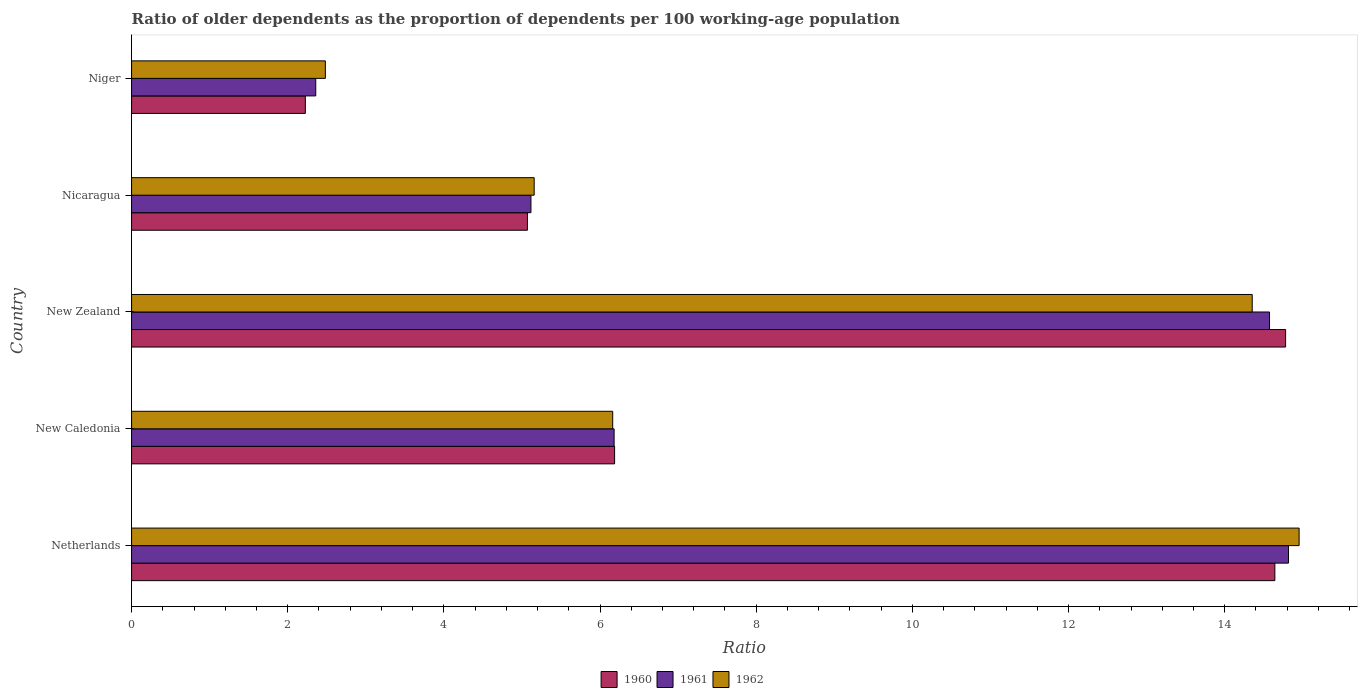How many groups of bars are there?
Your response must be concise. 5. Are the number of bars per tick equal to the number of legend labels?
Your answer should be compact. Yes. Are the number of bars on each tick of the Y-axis equal?
Provide a short and direct response. Yes. How many bars are there on the 4th tick from the top?
Your response must be concise. 3. What is the label of the 3rd group of bars from the top?
Your answer should be compact. New Zealand. What is the age dependency ratio(old) in 1961 in Netherlands?
Your answer should be compact. 14.82. Across all countries, what is the maximum age dependency ratio(old) in 1961?
Make the answer very short. 14.82. Across all countries, what is the minimum age dependency ratio(old) in 1962?
Provide a succinct answer. 2.48. In which country was the age dependency ratio(old) in 1961 minimum?
Your answer should be compact. Niger. What is the total age dependency ratio(old) in 1961 in the graph?
Provide a succinct answer. 43.04. What is the difference between the age dependency ratio(old) in 1962 in Netherlands and that in New Zealand?
Offer a terse response. 0.6. What is the difference between the age dependency ratio(old) in 1961 in New Zealand and the age dependency ratio(old) in 1962 in Nicaragua?
Make the answer very short. 9.42. What is the average age dependency ratio(old) in 1960 per country?
Your response must be concise. 8.58. What is the difference between the age dependency ratio(old) in 1960 and age dependency ratio(old) in 1961 in New Caledonia?
Keep it short and to the point. 0.01. In how many countries, is the age dependency ratio(old) in 1962 greater than 5.6 ?
Give a very brief answer. 3. What is the ratio of the age dependency ratio(old) in 1962 in New Caledonia to that in Niger?
Your answer should be very brief. 2.48. Is the difference between the age dependency ratio(old) in 1960 in New Caledonia and Nicaragua greater than the difference between the age dependency ratio(old) in 1961 in New Caledonia and Nicaragua?
Keep it short and to the point. Yes. What is the difference between the highest and the second highest age dependency ratio(old) in 1961?
Keep it short and to the point. 0.24. What is the difference between the highest and the lowest age dependency ratio(old) in 1962?
Keep it short and to the point. 12.47. Is it the case that in every country, the sum of the age dependency ratio(old) in 1960 and age dependency ratio(old) in 1962 is greater than the age dependency ratio(old) in 1961?
Offer a terse response. Yes. How many bars are there?
Your response must be concise. 15. How many countries are there in the graph?
Offer a very short reply. 5. Are the values on the major ticks of X-axis written in scientific E-notation?
Offer a very short reply. No. Does the graph contain any zero values?
Make the answer very short. No. Does the graph contain grids?
Keep it short and to the point. No. How many legend labels are there?
Make the answer very short. 3. What is the title of the graph?
Offer a very short reply. Ratio of older dependents as the proportion of dependents per 100 working-age population. Does "1987" appear as one of the legend labels in the graph?
Offer a terse response. No. What is the label or title of the X-axis?
Your response must be concise. Ratio. What is the Ratio in 1960 in Netherlands?
Your response must be concise. 14.64. What is the Ratio of 1961 in Netherlands?
Your answer should be compact. 14.82. What is the Ratio in 1962 in Netherlands?
Offer a very short reply. 14.95. What is the Ratio of 1960 in New Caledonia?
Offer a terse response. 6.19. What is the Ratio of 1961 in New Caledonia?
Provide a succinct answer. 6.18. What is the Ratio in 1962 in New Caledonia?
Ensure brevity in your answer.  6.16. What is the Ratio of 1960 in New Zealand?
Your answer should be compact. 14.78. What is the Ratio in 1961 in New Zealand?
Provide a short and direct response. 14.57. What is the Ratio in 1962 in New Zealand?
Keep it short and to the point. 14.35. What is the Ratio in 1960 in Nicaragua?
Your answer should be very brief. 5.07. What is the Ratio in 1961 in Nicaragua?
Give a very brief answer. 5.11. What is the Ratio in 1962 in Nicaragua?
Give a very brief answer. 5.16. What is the Ratio in 1960 in Niger?
Make the answer very short. 2.23. What is the Ratio of 1961 in Niger?
Offer a terse response. 2.36. What is the Ratio in 1962 in Niger?
Your answer should be very brief. 2.48. Across all countries, what is the maximum Ratio in 1960?
Keep it short and to the point. 14.78. Across all countries, what is the maximum Ratio of 1961?
Your answer should be very brief. 14.82. Across all countries, what is the maximum Ratio of 1962?
Offer a very short reply. 14.95. Across all countries, what is the minimum Ratio of 1960?
Give a very brief answer. 2.23. Across all countries, what is the minimum Ratio of 1961?
Provide a short and direct response. 2.36. Across all countries, what is the minimum Ratio in 1962?
Offer a terse response. 2.48. What is the total Ratio in 1960 in the graph?
Provide a short and direct response. 42.9. What is the total Ratio in 1961 in the graph?
Your answer should be very brief. 43.04. What is the total Ratio of 1962 in the graph?
Keep it short and to the point. 43.11. What is the difference between the Ratio in 1960 in Netherlands and that in New Caledonia?
Make the answer very short. 8.46. What is the difference between the Ratio of 1961 in Netherlands and that in New Caledonia?
Offer a very short reply. 8.64. What is the difference between the Ratio of 1962 in Netherlands and that in New Caledonia?
Your answer should be very brief. 8.79. What is the difference between the Ratio of 1960 in Netherlands and that in New Zealand?
Provide a succinct answer. -0.14. What is the difference between the Ratio in 1961 in Netherlands and that in New Zealand?
Offer a terse response. 0.24. What is the difference between the Ratio of 1962 in Netherlands and that in New Zealand?
Ensure brevity in your answer.  0.6. What is the difference between the Ratio of 1960 in Netherlands and that in Nicaragua?
Provide a short and direct response. 9.57. What is the difference between the Ratio of 1961 in Netherlands and that in Nicaragua?
Your response must be concise. 9.7. What is the difference between the Ratio of 1962 in Netherlands and that in Nicaragua?
Offer a terse response. 9.8. What is the difference between the Ratio in 1960 in Netherlands and that in Niger?
Give a very brief answer. 12.42. What is the difference between the Ratio in 1961 in Netherlands and that in Niger?
Your answer should be very brief. 12.46. What is the difference between the Ratio in 1962 in Netherlands and that in Niger?
Provide a succinct answer. 12.47. What is the difference between the Ratio of 1960 in New Caledonia and that in New Zealand?
Make the answer very short. -8.59. What is the difference between the Ratio in 1961 in New Caledonia and that in New Zealand?
Make the answer very short. -8.39. What is the difference between the Ratio in 1962 in New Caledonia and that in New Zealand?
Make the answer very short. -8.19. What is the difference between the Ratio of 1960 in New Caledonia and that in Nicaragua?
Offer a terse response. 1.12. What is the difference between the Ratio of 1961 in New Caledonia and that in Nicaragua?
Your answer should be compact. 1.07. What is the difference between the Ratio of 1962 in New Caledonia and that in Nicaragua?
Ensure brevity in your answer.  1.01. What is the difference between the Ratio in 1960 in New Caledonia and that in Niger?
Ensure brevity in your answer.  3.96. What is the difference between the Ratio of 1961 in New Caledonia and that in Niger?
Keep it short and to the point. 3.82. What is the difference between the Ratio in 1962 in New Caledonia and that in Niger?
Ensure brevity in your answer.  3.68. What is the difference between the Ratio in 1960 in New Zealand and that in Nicaragua?
Ensure brevity in your answer.  9.71. What is the difference between the Ratio of 1961 in New Zealand and that in Nicaragua?
Your answer should be compact. 9.46. What is the difference between the Ratio of 1962 in New Zealand and that in Nicaragua?
Make the answer very short. 9.2. What is the difference between the Ratio in 1960 in New Zealand and that in Niger?
Your answer should be compact. 12.55. What is the difference between the Ratio in 1961 in New Zealand and that in Niger?
Keep it short and to the point. 12.22. What is the difference between the Ratio in 1962 in New Zealand and that in Niger?
Keep it short and to the point. 11.87. What is the difference between the Ratio of 1960 in Nicaragua and that in Niger?
Offer a terse response. 2.84. What is the difference between the Ratio in 1961 in Nicaragua and that in Niger?
Your answer should be compact. 2.76. What is the difference between the Ratio in 1962 in Nicaragua and that in Niger?
Ensure brevity in your answer.  2.67. What is the difference between the Ratio in 1960 in Netherlands and the Ratio in 1961 in New Caledonia?
Provide a succinct answer. 8.46. What is the difference between the Ratio of 1960 in Netherlands and the Ratio of 1962 in New Caledonia?
Offer a terse response. 8.48. What is the difference between the Ratio in 1961 in Netherlands and the Ratio in 1962 in New Caledonia?
Keep it short and to the point. 8.66. What is the difference between the Ratio in 1960 in Netherlands and the Ratio in 1961 in New Zealand?
Provide a short and direct response. 0.07. What is the difference between the Ratio in 1960 in Netherlands and the Ratio in 1962 in New Zealand?
Provide a short and direct response. 0.29. What is the difference between the Ratio in 1961 in Netherlands and the Ratio in 1962 in New Zealand?
Your answer should be compact. 0.46. What is the difference between the Ratio of 1960 in Netherlands and the Ratio of 1961 in Nicaragua?
Ensure brevity in your answer.  9.53. What is the difference between the Ratio in 1960 in Netherlands and the Ratio in 1962 in Nicaragua?
Ensure brevity in your answer.  9.49. What is the difference between the Ratio in 1961 in Netherlands and the Ratio in 1962 in Nicaragua?
Provide a succinct answer. 9.66. What is the difference between the Ratio in 1960 in Netherlands and the Ratio in 1961 in Niger?
Make the answer very short. 12.28. What is the difference between the Ratio in 1960 in Netherlands and the Ratio in 1962 in Niger?
Your response must be concise. 12.16. What is the difference between the Ratio of 1961 in Netherlands and the Ratio of 1962 in Niger?
Ensure brevity in your answer.  12.34. What is the difference between the Ratio of 1960 in New Caledonia and the Ratio of 1961 in New Zealand?
Give a very brief answer. -8.39. What is the difference between the Ratio of 1960 in New Caledonia and the Ratio of 1962 in New Zealand?
Make the answer very short. -8.17. What is the difference between the Ratio of 1961 in New Caledonia and the Ratio of 1962 in New Zealand?
Provide a short and direct response. -8.17. What is the difference between the Ratio in 1960 in New Caledonia and the Ratio in 1961 in Nicaragua?
Make the answer very short. 1.07. What is the difference between the Ratio in 1960 in New Caledonia and the Ratio in 1962 in Nicaragua?
Your answer should be very brief. 1.03. What is the difference between the Ratio of 1961 in New Caledonia and the Ratio of 1962 in Nicaragua?
Your response must be concise. 1.02. What is the difference between the Ratio of 1960 in New Caledonia and the Ratio of 1961 in Niger?
Your response must be concise. 3.83. What is the difference between the Ratio of 1960 in New Caledonia and the Ratio of 1962 in Niger?
Offer a very short reply. 3.7. What is the difference between the Ratio in 1961 in New Caledonia and the Ratio in 1962 in Niger?
Make the answer very short. 3.7. What is the difference between the Ratio of 1960 in New Zealand and the Ratio of 1961 in Nicaragua?
Your response must be concise. 9.67. What is the difference between the Ratio in 1960 in New Zealand and the Ratio in 1962 in Nicaragua?
Provide a succinct answer. 9.62. What is the difference between the Ratio of 1961 in New Zealand and the Ratio of 1962 in Nicaragua?
Give a very brief answer. 9.42. What is the difference between the Ratio in 1960 in New Zealand and the Ratio in 1961 in Niger?
Make the answer very short. 12.42. What is the difference between the Ratio of 1960 in New Zealand and the Ratio of 1962 in Niger?
Offer a very short reply. 12.3. What is the difference between the Ratio in 1961 in New Zealand and the Ratio in 1962 in Niger?
Provide a succinct answer. 12.09. What is the difference between the Ratio of 1960 in Nicaragua and the Ratio of 1961 in Niger?
Give a very brief answer. 2.71. What is the difference between the Ratio of 1960 in Nicaragua and the Ratio of 1962 in Niger?
Offer a terse response. 2.59. What is the difference between the Ratio in 1961 in Nicaragua and the Ratio in 1962 in Niger?
Your answer should be compact. 2.63. What is the average Ratio of 1960 per country?
Your response must be concise. 8.58. What is the average Ratio of 1961 per country?
Ensure brevity in your answer.  8.61. What is the average Ratio in 1962 per country?
Your answer should be compact. 8.62. What is the difference between the Ratio in 1960 and Ratio in 1961 in Netherlands?
Keep it short and to the point. -0.17. What is the difference between the Ratio in 1960 and Ratio in 1962 in Netherlands?
Provide a short and direct response. -0.31. What is the difference between the Ratio of 1961 and Ratio of 1962 in Netherlands?
Your answer should be compact. -0.14. What is the difference between the Ratio of 1960 and Ratio of 1961 in New Caledonia?
Keep it short and to the point. 0.01. What is the difference between the Ratio in 1960 and Ratio in 1962 in New Caledonia?
Provide a succinct answer. 0.02. What is the difference between the Ratio of 1961 and Ratio of 1962 in New Caledonia?
Offer a very short reply. 0.02. What is the difference between the Ratio in 1960 and Ratio in 1961 in New Zealand?
Offer a very short reply. 0.21. What is the difference between the Ratio in 1960 and Ratio in 1962 in New Zealand?
Your answer should be compact. 0.43. What is the difference between the Ratio in 1961 and Ratio in 1962 in New Zealand?
Offer a very short reply. 0.22. What is the difference between the Ratio of 1960 and Ratio of 1961 in Nicaragua?
Keep it short and to the point. -0.04. What is the difference between the Ratio in 1960 and Ratio in 1962 in Nicaragua?
Keep it short and to the point. -0.09. What is the difference between the Ratio of 1961 and Ratio of 1962 in Nicaragua?
Your answer should be compact. -0.04. What is the difference between the Ratio of 1960 and Ratio of 1961 in Niger?
Make the answer very short. -0.13. What is the difference between the Ratio in 1960 and Ratio in 1962 in Niger?
Your answer should be compact. -0.26. What is the difference between the Ratio of 1961 and Ratio of 1962 in Niger?
Offer a very short reply. -0.12. What is the ratio of the Ratio of 1960 in Netherlands to that in New Caledonia?
Provide a short and direct response. 2.37. What is the ratio of the Ratio of 1961 in Netherlands to that in New Caledonia?
Your response must be concise. 2.4. What is the ratio of the Ratio in 1962 in Netherlands to that in New Caledonia?
Make the answer very short. 2.43. What is the ratio of the Ratio in 1960 in Netherlands to that in New Zealand?
Ensure brevity in your answer.  0.99. What is the ratio of the Ratio of 1961 in Netherlands to that in New Zealand?
Offer a very short reply. 1.02. What is the ratio of the Ratio in 1962 in Netherlands to that in New Zealand?
Your answer should be very brief. 1.04. What is the ratio of the Ratio of 1960 in Netherlands to that in Nicaragua?
Your response must be concise. 2.89. What is the ratio of the Ratio in 1961 in Netherlands to that in Nicaragua?
Provide a succinct answer. 2.9. What is the ratio of the Ratio in 1962 in Netherlands to that in Nicaragua?
Offer a very short reply. 2.9. What is the ratio of the Ratio of 1960 in Netherlands to that in Niger?
Make the answer very short. 6.58. What is the ratio of the Ratio of 1961 in Netherlands to that in Niger?
Give a very brief answer. 6.28. What is the ratio of the Ratio in 1962 in Netherlands to that in Niger?
Make the answer very short. 6.02. What is the ratio of the Ratio of 1960 in New Caledonia to that in New Zealand?
Keep it short and to the point. 0.42. What is the ratio of the Ratio of 1961 in New Caledonia to that in New Zealand?
Give a very brief answer. 0.42. What is the ratio of the Ratio in 1962 in New Caledonia to that in New Zealand?
Make the answer very short. 0.43. What is the ratio of the Ratio of 1960 in New Caledonia to that in Nicaragua?
Provide a succinct answer. 1.22. What is the ratio of the Ratio in 1961 in New Caledonia to that in Nicaragua?
Provide a succinct answer. 1.21. What is the ratio of the Ratio in 1962 in New Caledonia to that in Nicaragua?
Ensure brevity in your answer.  1.2. What is the ratio of the Ratio in 1960 in New Caledonia to that in Niger?
Offer a very short reply. 2.78. What is the ratio of the Ratio in 1961 in New Caledonia to that in Niger?
Your answer should be compact. 2.62. What is the ratio of the Ratio in 1962 in New Caledonia to that in Niger?
Offer a very short reply. 2.48. What is the ratio of the Ratio of 1960 in New Zealand to that in Nicaragua?
Your response must be concise. 2.92. What is the ratio of the Ratio in 1961 in New Zealand to that in Nicaragua?
Provide a succinct answer. 2.85. What is the ratio of the Ratio of 1962 in New Zealand to that in Nicaragua?
Your answer should be very brief. 2.78. What is the ratio of the Ratio in 1960 in New Zealand to that in Niger?
Make the answer very short. 6.64. What is the ratio of the Ratio in 1961 in New Zealand to that in Niger?
Provide a succinct answer. 6.18. What is the ratio of the Ratio of 1962 in New Zealand to that in Niger?
Offer a very short reply. 5.78. What is the ratio of the Ratio of 1960 in Nicaragua to that in Niger?
Ensure brevity in your answer.  2.28. What is the ratio of the Ratio in 1961 in Nicaragua to that in Niger?
Ensure brevity in your answer.  2.17. What is the ratio of the Ratio of 1962 in Nicaragua to that in Niger?
Your answer should be compact. 2.08. What is the difference between the highest and the second highest Ratio of 1960?
Offer a very short reply. 0.14. What is the difference between the highest and the second highest Ratio in 1961?
Provide a succinct answer. 0.24. What is the difference between the highest and the second highest Ratio in 1962?
Your answer should be compact. 0.6. What is the difference between the highest and the lowest Ratio of 1960?
Keep it short and to the point. 12.55. What is the difference between the highest and the lowest Ratio of 1961?
Ensure brevity in your answer.  12.46. What is the difference between the highest and the lowest Ratio in 1962?
Ensure brevity in your answer.  12.47. 